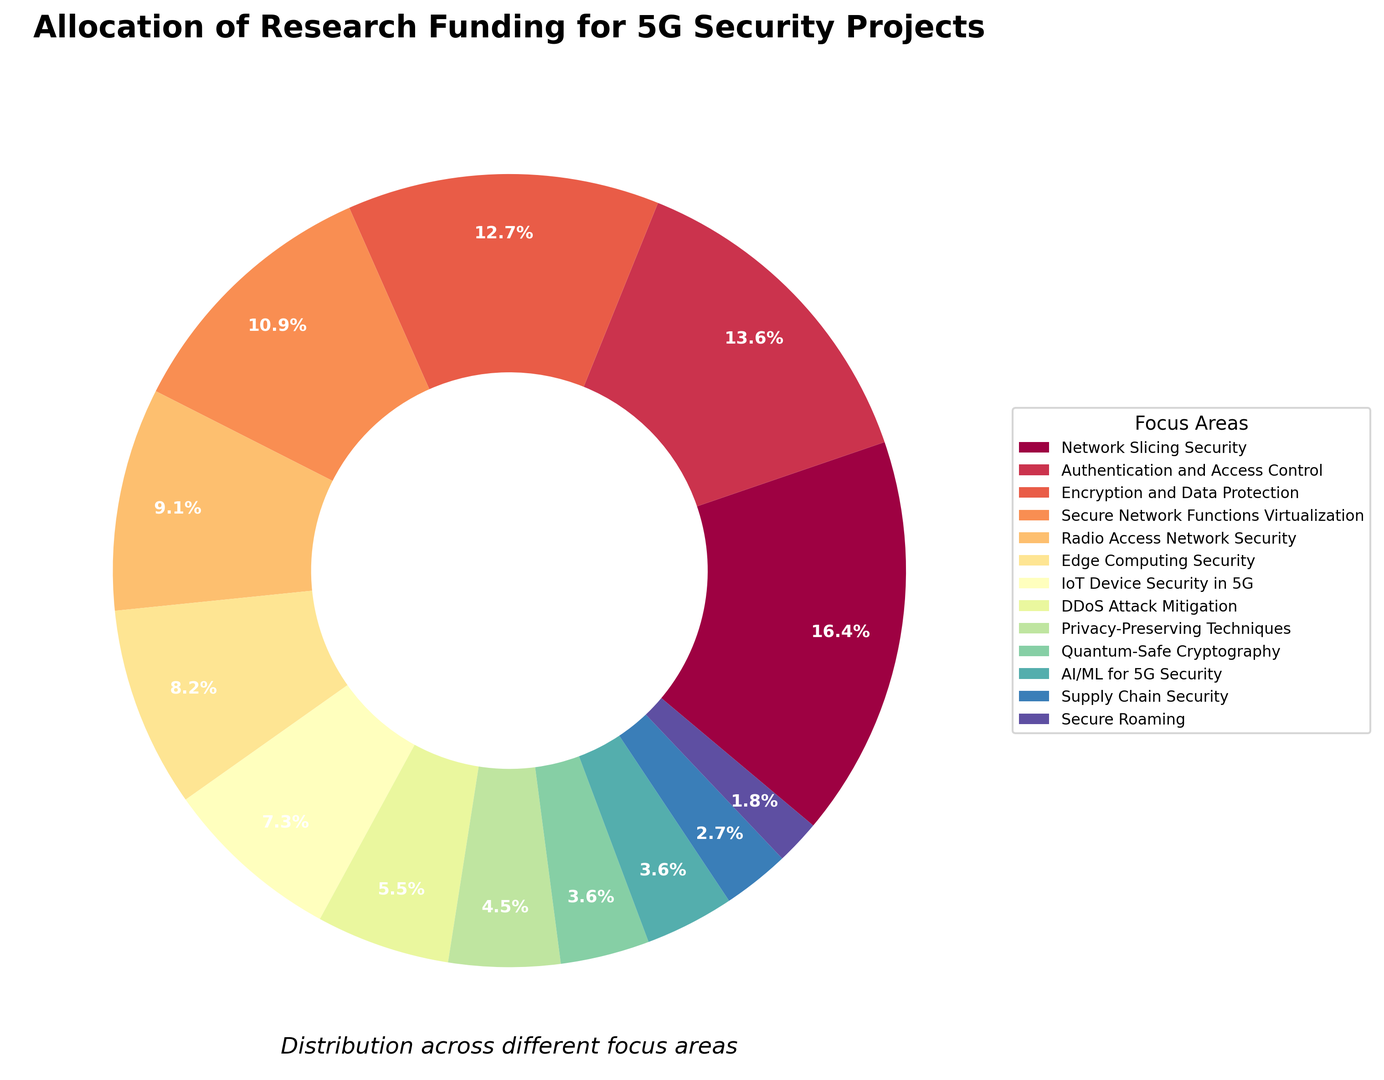Which focus area received the highest allocation of research funding? The focus area with the highest percentage on the ring chart represents the area with the highest allocation of research funding.
Answer: Network Slicing Security How much more funding percentage did Network Slicing Security receive compared to Secure Roaming? Subtract the funding percentage of Secure Roaming (2%) from that of Network Slicing Security (18%).
Answer: 16% What is the total percentage of funding allocated to Authentication and Access Control, and Encryption and Data Protection? Add the funding percentages of Authentication and Access Control (15%) and Encryption and Data Protection (14%).
Answer: 29% Which focus area received a greater funding percentage, Edge Computing Security or IoT Device Security in 5G? Compare the funding percentages of Edge Computing Security (9%) and IoT Device Security in 5G (8%).
Answer: Edge Computing Security Which focus area has a funding percentage that is closest to the average funding percentage across all areas? Calculate the average funding percentage by summing all percentages and dividing by the number of focus areas. Compare each area’s percentage to this average. The average is (18+15+14+12+10+9+8+6+5+4+4+3+2) / 13 = 8.615%.
Answer: IoT Device Security in 5G What is the combined funding percentage for Quantum-Safe Cryptography and AI/ML for 5G Security? Add the funding percentages of Quantum-Safe Cryptography (4%) and AI/ML for 5G Security (4%).
Answer: 8% Which focus areas received less than 10% funding? Identify all focus areas with funding percentages less than 10%.
Answer: Radio Access Network Security, Edge Computing Security, IoT Device Security in 5G, DDoS Attack Mitigation, Privacy-Preserving Techniques, Quantum-Safe Cryptography, Supply Chain Security, Secure Roaming What is the difference in funding percentage between Authentication and Access Control and Edge Computing Security? Subtract the funding percentage of Edge Computing Security (9%) from that of Authentication and Access Control (15%).
Answer: 6% Sum the funding percentages of Secure Network Functions Virtualization and Radio Access Network Security, then subtract the funding percentage for Quantum-Safe Cryptography. First sum the funding percentages of Secure Network Functions Virtualization (12%) and Radio Access Network Security (10%), then subtract the percentage for Quantum-Safe Cryptography (4%). (12 + 10) - 4 = 18%
Answer: 18% Which focus area located in the inner ring segment received the lowest funding? From the inner ring segments, identify the segment with the smallest percentage.
Answer: Secure Roaming 